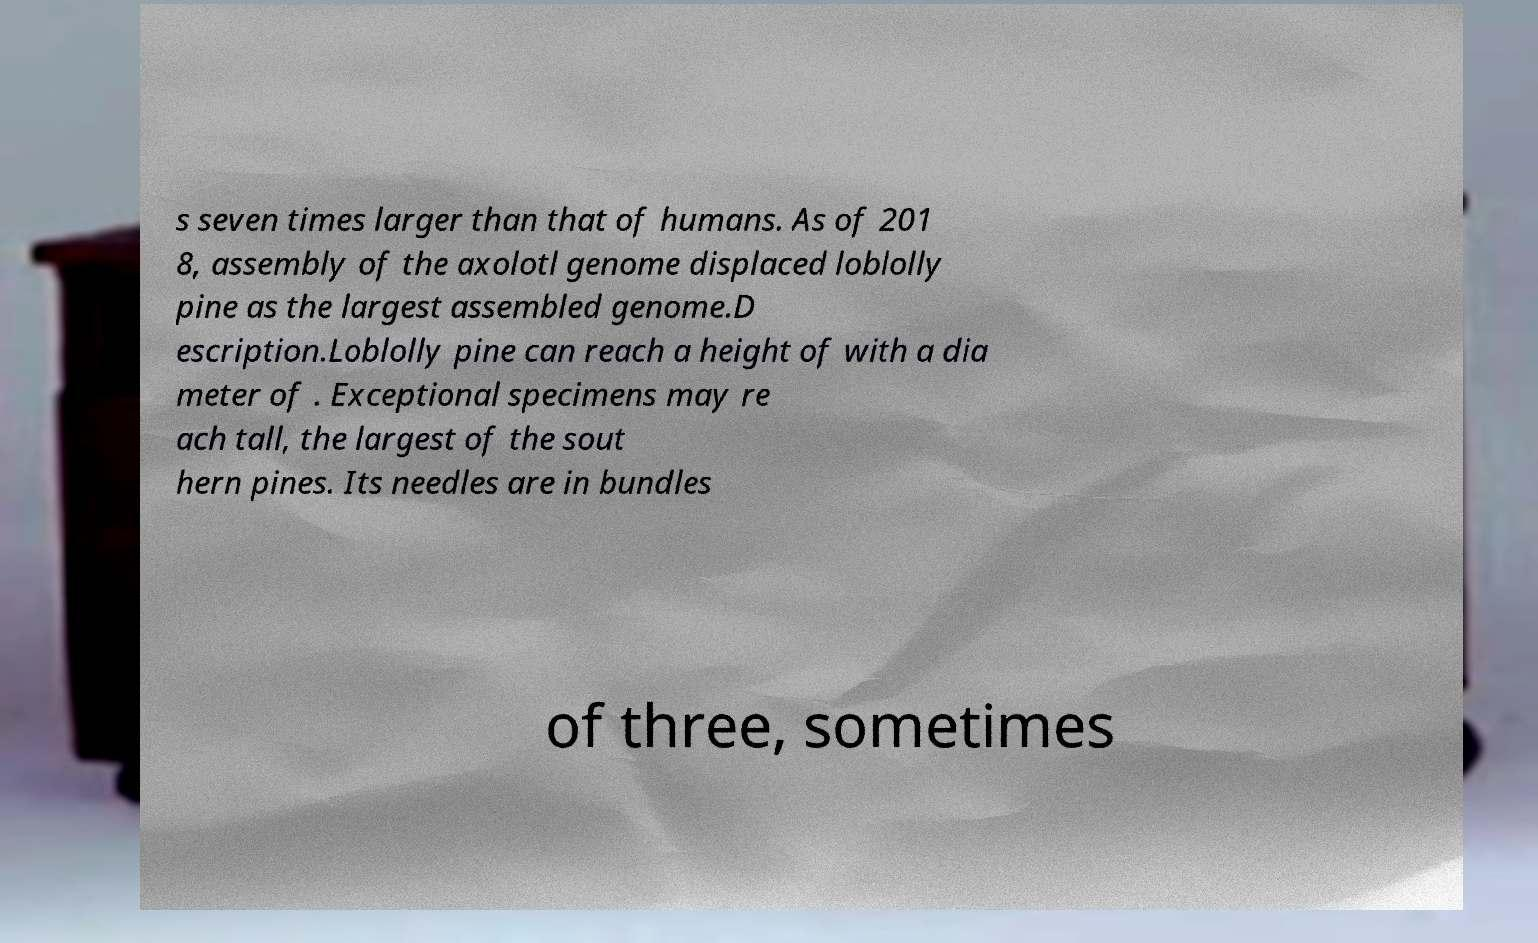Could you assist in decoding the text presented in this image and type it out clearly? s seven times larger than that of humans. As of 201 8, assembly of the axolotl genome displaced loblolly pine as the largest assembled genome.D escription.Loblolly pine can reach a height of with a dia meter of . Exceptional specimens may re ach tall, the largest of the sout hern pines. Its needles are in bundles of three, sometimes 